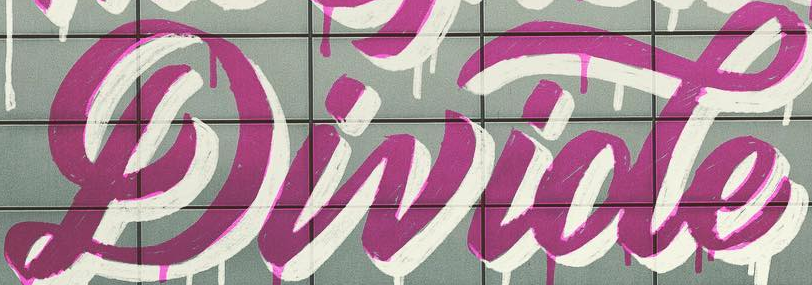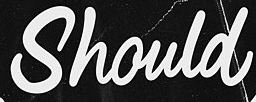What text is displayed in these images sequentially, separated by a semicolon? Divide; Should 